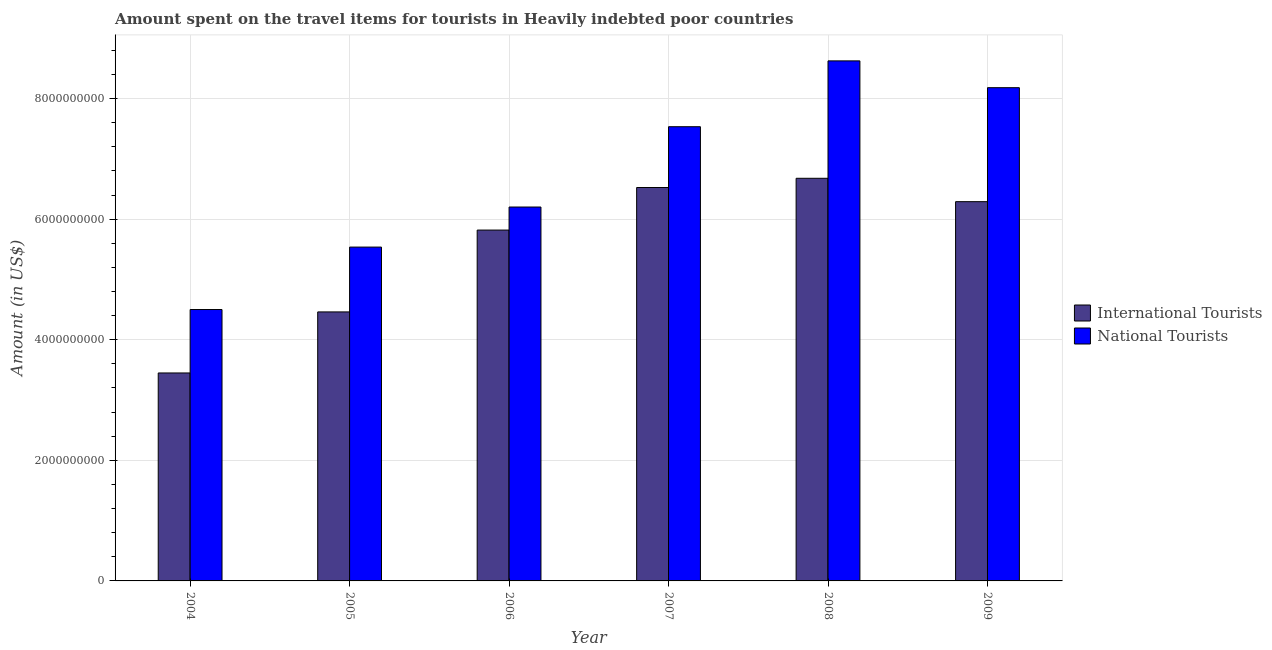How many different coloured bars are there?
Your response must be concise. 2. How many groups of bars are there?
Keep it short and to the point. 6. Are the number of bars per tick equal to the number of legend labels?
Provide a short and direct response. Yes. Are the number of bars on each tick of the X-axis equal?
Your answer should be compact. Yes. How many bars are there on the 1st tick from the left?
Offer a very short reply. 2. How many bars are there on the 5th tick from the right?
Your answer should be very brief. 2. What is the label of the 2nd group of bars from the left?
Your answer should be very brief. 2005. What is the amount spent on travel items of international tourists in 2005?
Provide a succinct answer. 4.46e+09. Across all years, what is the maximum amount spent on travel items of international tourists?
Offer a very short reply. 6.68e+09. Across all years, what is the minimum amount spent on travel items of national tourists?
Your answer should be compact. 4.50e+09. In which year was the amount spent on travel items of national tourists minimum?
Keep it short and to the point. 2004. What is the total amount spent on travel items of national tourists in the graph?
Your response must be concise. 4.06e+1. What is the difference between the amount spent on travel items of national tourists in 2005 and that in 2009?
Offer a very short reply. -2.64e+09. What is the difference between the amount spent on travel items of national tourists in 2006 and the amount spent on travel items of international tourists in 2008?
Keep it short and to the point. -2.42e+09. What is the average amount spent on travel items of national tourists per year?
Ensure brevity in your answer.  6.76e+09. In how many years, is the amount spent on travel items of international tourists greater than 4400000000 US$?
Keep it short and to the point. 5. What is the ratio of the amount spent on travel items of national tourists in 2004 to that in 2009?
Your response must be concise. 0.55. Is the amount spent on travel items of international tourists in 2004 less than that in 2008?
Offer a very short reply. Yes. What is the difference between the highest and the second highest amount spent on travel items of international tourists?
Offer a very short reply. 1.53e+08. What is the difference between the highest and the lowest amount spent on travel items of national tourists?
Give a very brief answer. 4.12e+09. Is the sum of the amount spent on travel items of national tourists in 2004 and 2007 greater than the maximum amount spent on travel items of international tourists across all years?
Offer a very short reply. Yes. What does the 1st bar from the left in 2009 represents?
Provide a short and direct response. International Tourists. What does the 2nd bar from the right in 2005 represents?
Provide a short and direct response. International Tourists. Are all the bars in the graph horizontal?
Keep it short and to the point. No. How many years are there in the graph?
Provide a short and direct response. 6. What is the difference between two consecutive major ticks on the Y-axis?
Give a very brief answer. 2.00e+09. Are the values on the major ticks of Y-axis written in scientific E-notation?
Offer a terse response. No. Does the graph contain grids?
Your answer should be compact. Yes. Where does the legend appear in the graph?
Offer a very short reply. Center right. How many legend labels are there?
Your response must be concise. 2. How are the legend labels stacked?
Give a very brief answer. Vertical. What is the title of the graph?
Your answer should be compact. Amount spent on the travel items for tourists in Heavily indebted poor countries. What is the label or title of the X-axis?
Offer a very short reply. Year. What is the Amount (in US$) in International Tourists in 2004?
Your response must be concise. 3.45e+09. What is the Amount (in US$) in National Tourists in 2004?
Your answer should be very brief. 4.50e+09. What is the Amount (in US$) in International Tourists in 2005?
Provide a short and direct response. 4.46e+09. What is the Amount (in US$) of National Tourists in 2005?
Offer a terse response. 5.54e+09. What is the Amount (in US$) of International Tourists in 2006?
Offer a very short reply. 5.82e+09. What is the Amount (in US$) of National Tourists in 2006?
Make the answer very short. 6.20e+09. What is the Amount (in US$) of International Tourists in 2007?
Provide a succinct answer. 6.53e+09. What is the Amount (in US$) in National Tourists in 2007?
Your answer should be compact. 7.53e+09. What is the Amount (in US$) of International Tourists in 2008?
Ensure brevity in your answer.  6.68e+09. What is the Amount (in US$) of National Tourists in 2008?
Give a very brief answer. 8.63e+09. What is the Amount (in US$) of International Tourists in 2009?
Make the answer very short. 6.29e+09. What is the Amount (in US$) in National Tourists in 2009?
Give a very brief answer. 8.18e+09. Across all years, what is the maximum Amount (in US$) of International Tourists?
Provide a succinct answer. 6.68e+09. Across all years, what is the maximum Amount (in US$) of National Tourists?
Offer a very short reply. 8.63e+09. Across all years, what is the minimum Amount (in US$) of International Tourists?
Make the answer very short. 3.45e+09. Across all years, what is the minimum Amount (in US$) of National Tourists?
Your answer should be compact. 4.50e+09. What is the total Amount (in US$) in International Tourists in the graph?
Your answer should be compact. 3.32e+1. What is the total Amount (in US$) of National Tourists in the graph?
Your answer should be very brief. 4.06e+1. What is the difference between the Amount (in US$) in International Tourists in 2004 and that in 2005?
Your response must be concise. -1.01e+09. What is the difference between the Amount (in US$) in National Tourists in 2004 and that in 2005?
Keep it short and to the point. -1.04e+09. What is the difference between the Amount (in US$) in International Tourists in 2004 and that in 2006?
Make the answer very short. -2.37e+09. What is the difference between the Amount (in US$) of National Tourists in 2004 and that in 2006?
Provide a succinct answer. -1.70e+09. What is the difference between the Amount (in US$) of International Tourists in 2004 and that in 2007?
Your answer should be compact. -3.08e+09. What is the difference between the Amount (in US$) of National Tourists in 2004 and that in 2007?
Give a very brief answer. -3.03e+09. What is the difference between the Amount (in US$) of International Tourists in 2004 and that in 2008?
Offer a very short reply. -3.23e+09. What is the difference between the Amount (in US$) of National Tourists in 2004 and that in 2008?
Keep it short and to the point. -4.12e+09. What is the difference between the Amount (in US$) in International Tourists in 2004 and that in 2009?
Keep it short and to the point. -2.84e+09. What is the difference between the Amount (in US$) in National Tourists in 2004 and that in 2009?
Your answer should be very brief. -3.68e+09. What is the difference between the Amount (in US$) in International Tourists in 2005 and that in 2006?
Keep it short and to the point. -1.36e+09. What is the difference between the Amount (in US$) of National Tourists in 2005 and that in 2006?
Your answer should be compact. -6.65e+08. What is the difference between the Amount (in US$) of International Tourists in 2005 and that in 2007?
Offer a very short reply. -2.06e+09. What is the difference between the Amount (in US$) in National Tourists in 2005 and that in 2007?
Ensure brevity in your answer.  -2.00e+09. What is the difference between the Amount (in US$) of International Tourists in 2005 and that in 2008?
Provide a succinct answer. -2.22e+09. What is the difference between the Amount (in US$) in National Tourists in 2005 and that in 2008?
Ensure brevity in your answer.  -3.09e+09. What is the difference between the Amount (in US$) in International Tourists in 2005 and that in 2009?
Offer a very short reply. -1.83e+09. What is the difference between the Amount (in US$) of National Tourists in 2005 and that in 2009?
Give a very brief answer. -2.64e+09. What is the difference between the Amount (in US$) in International Tourists in 2006 and that in 2007?
Ensure brevity in your answer.  -7.06e+08. What is the difference between the Amount (in US$) of National Tourists in 2006 and that in 2007?
Keep it short and to the point. -1.33e+09. What is the difference between the Amount (in US$) of International Tourists in 2006 and that in 2008?
Ensure brevity in your answer.  -8.59e+08. What is the difference between the Amount (in US$) in National Tourists in 2006 and that in 2008?
Offer a terse response. -2.42e+09. What is the difference between the Amount (in US$) of International Tourists in 2006 and that in 2009?
Provide a short and direct response. -4.71e+08. What is the difference between the Amount (in US$) of National Tourists in 2006 and that in 2009?
Keep it short and to the point. -1.98e+09. What is the difference between the Amount (in US$) of International Tourists in 2007 and that in 2008?
Give a very brief answer. -1.53e+08. What is the difference between the Amount (in US$) in National Tourists in 2007 and that in 2008?
Your answer should be very brief. -1.09e+09. What is the difference between the Amount (in US$) of International Tourists in 2007 and that in 2009?
Give a very brief answer. 2.35e+08. What is the difference between the Amount (in US$) in National Tourists in 2007 and that in 2009?
Give a very brief answer. -6.48e+08. What is the difference between the Amount (in US$) of International Tourists in 2008 and that in 2009?
Your response must be concise. 3.88e+08. What is the difference between the Amount (in US$) of National Tourists in 2008 and that in 2009?
Your answer should be compact. 4.44e+08. What is the difference between the Amount (in US$) of International Tourists in 2004 and the Amount (in US$) of National Tourists in 2005?
Your response must be concise. -2.09e+09. What is the difference between the Amount (in US$) in International Tourists in 2004 and the Amount (in US$) in National Tourists in 2006?
Ensure brevity in your answer.  -2.75e+09. What is the difference between the Amount (in US$) of International Tourists in 2004 and the Amount (in US$) of National Tourists in 2007?
Keep it short and to the point. -4.08e+09. What is the difference between the Amount (in US$) of International Tourists in 2004 and the Amount (in US$) of National Tourists in 2008?
Offer a very short reply. -5.18e+09. What is the difference between the Amount (in US$) of International Tourists in 2004 and the Amount (in US$) of National Tourists in 2009?
Keep it short and to the point. -4.73e+09. What is the difference between the Amount (in US$) in International Tourists in 2005 and the Amount (in US$) in National Tourists in 2006?
Keep it short and to the point. -1.74e+09. What is the difference between the Amount (in US$) in International Tourists in 2005 and the Amount (in US$) in National Tourists in 2007?
Provide a short and direct response. -3.07e+09. What is the difference between the Amount (in US$) of International Tourists in 2005 and the Amount (in US$) of National Tourists in 2008?
Provide a succinct answer. -4.16e+09. What is the difference between the Amount (in US$) in International Tourists in 2005 and the Amount (in US$) in National Tourists in 2009?
Provide a succinct answer. -3.72e+09. What is the difference between the Amount (in US$) of International Tourists in 2006 and the Amount (in US$) of National Tourists in 2007?
Your answer should be compact. -1.71e+09. What is the difference between the Amount (in US$) of International Tourists in 2006 and the Amount (in US$) of National Tourists in 2008?
Provide a succinct answer. -2.81e+09. What is the difference between the Amount (in US$) of International Tourists in 2006 and the Amount (in US$) of National Tourists in 2009?
Your answer should be compact. -2.36e+09. What is the difference between the Amount (in US$) in International Tourists in 2007 and the Amount (in US$) in National Tourists in 2008?
Offer a very short reply. -2.10e+09. What is the difference between the Amount (in US$) in International Tourists in 2007 and the Amount (in US$) in National Tourists in 2009?
Offer a very short reply. -1.66e+09. What is the difference between the Amount (in US$) in International Tourists in 2008 and the Amount (in US$) in National Tourists in 2009?
Give a very brief answer. -1.50e+09. What is the average Amount (in US$) in International Tourists per year?
Provide a short and direct response. 5.54e+09. What is the average Amount (in US$) of National Tourists per year?
Keep it short and to the point. 6.76e+09. In the year 2004, what is the difference between the Amount (in US$) in International Tourists and Amount (in US$) in National Tourists?
Your answer should be very brief. -1.05e+09. In the year 2005, what is the difference between the Amount (in US$) in International Tourists and Amount (in US$) in National Tourists?
Your answer should be compact. -1.08e+09. In the year 2006, what is the difference between the Amount (in US$) of International Tourists and Amount (in US$) of National Tourists?
Provide a succinct answer. -3.82e+08. In the year 2007, what is the difference between the Amount (in US$) of International Tourists and Amount (in US$) of National Tourists?
Give a very brief answer. -1.01e+09. In the year 2008, what is the difference between the Amount (in US$) in International Tourists and Amount (in US$) in National Tourists?
Your answer should be very brief. -1.95e+09. In the year 2009, what is the difference between the Amount (in US$) of International Tourists and Amount (in US$) of National Tourists?
Offer a terse response. -1.89e+09. What is the ratio of the Amount (in US$) in International Tourists in 2004 to that in 2005?
Keep it short and to the point. 0.77. What is the ratio of the Amount (in US$) in National Tourists in 2004 to that in 2005?
Offer a terse response. 0.81. What is the ratio of the Amount (in US$) in International Tourists in 2004 to that in 2006?
Make the answer very short. 0.59. What is the ratio of the Amount (in US$) in National Tourists in 2004 to that in 2006?
Keep it short and to the point. 0.73. What is the ratio of the Amount (in US$) of International Tourists in 2004 to that in 2007?
Provide a succinct answer. 0.53. What is the ratio of the Amount (in US$) in National Tourists in 2004 to that in 2007?
Ensure brevity in your answer.  0.6. What is the ratio of the Amount (in US$) of International Tourists in 2004 to that in 2008?
Keep it short and to the point. 0.52. What is the ratio of the Amount (in US$) of National Tourists in 2004 to that in 2008?
Provide a succinct answer. 0.52. What is the ratio of the Amount (in US$) in International Tourists in 2004 to that in 2009?
Provide a short and direct response. 0.55. What is the ratio of the Amount (in US$) in National Tourists in 2004 to that in 2009?
Your answer should be very brief. 0.55. What is the ratio of the Amount (in US$) of International Tourists in 2005 to that in 2006?
Ensure brevity in your answer.  0.77. What is the ratio of the Amount (in US$) of National Tourists in 2005 to that in 2006?
Give a very brief answer. 0.89. What is the ratio of the Amount (in US$) of International Tourists in 2005 to that in 2007?
Offer a very short reply. 0.68. What is the ratio of the Amount (in US$) of National Tourists in 2005 to that in 2007?
Ensure brevity in your answer.  0.73. What is the ratio of the Amount (in US$) of International Tourists in 2005 to that in 2008?
Offer a very short reply. 0.67. What is the ratio of the Amount (in US$) of National Tourists in 2005 to that in 2008?
Give a very brief answer. 0.64. What is the ratio of the Amount (in US$) in International Tourists in 2005 to that in 2009?
Keep it short and to the point. 0.71. What is the ratio of the Amount (in US$) in National Tourists in 2005 to that in 2009?
Make the answer very short. 0.68. What is the ratio of the Amount (in US$) in International Tourists in 2006 to that in 2007?
Your answer should be very brief. 0.89. What is the ratio of the Amount (in US$) in National Tourists in 2006 to that in 2007?
Provide a short and direct response. 0.82. What is the ratio of the Amount (in US$) in International Tourists in 2006 to that in 2008?
Make the answer very short. 0.87. What is the ratio of the Amount (in US$) in National Tourists in 2006 to that in 2008?
Offer a terse response. 0.72. What is the ratio of the Amount (in US$) of International Tourists in 2006 to that in 2009?
Give a very brief answer. 0.93. What is the ratio of the Amount (in US$) of National Tourists in 2006 to that in 2009?
Give a very brief answer. 0.76. What is the ratio of the Amount (in US$) in International Tourists in 2007 to that in 2008?
Give a very brief answer. 0.98. What is the ratio of the Amount (in US$) of National Tourists in 2007 to that in 2008?
Your answer should be very brief. 0.87. What is the ratio of the Amount (in US$) of International Tourists in 2007 to that in 2009?
Ensure brevity in your answer.  1.04. What is the ratio of the Amount (in US$) in National Tourists in 2007 to that in 2009?
Provide a short and direct response. 0.92. What is the ratio of the Amount (in US$) in International Tourists in 2008 to that in 2009?
Make the answer very short. 1.06. What is the ratio of the Amount (in US$) in National Tourists in 2008 to that in 2009?
Your answer should be very brief. 1.05. What is the difference between the highest and the second highest Amount (in US$) of International Tourists?
Provide a short and direct response. 1.53e+08. What is the difference between the highest and the second highest Amount (in US$) in National Tourists?
Keep it short and to the point. 4.44e+08. What is the difference between the highest and the lowest Amount (in US$) of International Tourists?
Your answer should be compact. 3.23e+09. What is the difference between the highest and the lowest Amount (in US$) of National Tourists?
Provide a succinct answer. 4.12e+09. 